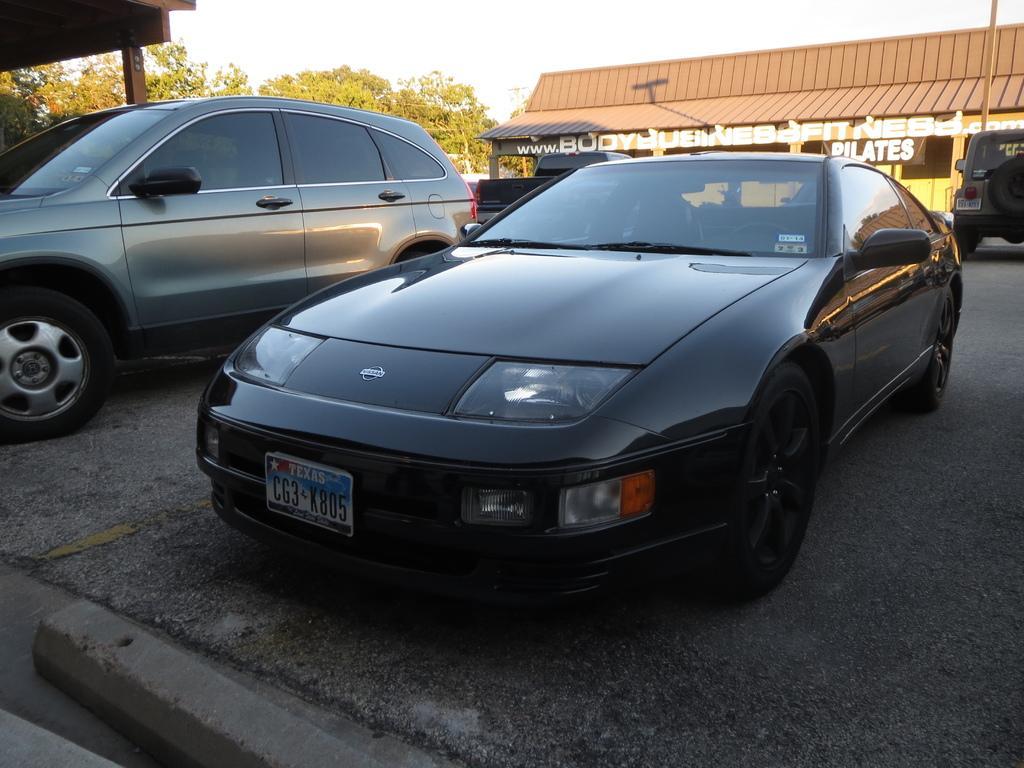Please provide a concise description of this image. In this image, we can see some trees and vehicle. There is a shelter in the top left of the image. There is a shed in the top right of the image. There is a sky at the top of the image. There is a pole in front of the shed. 